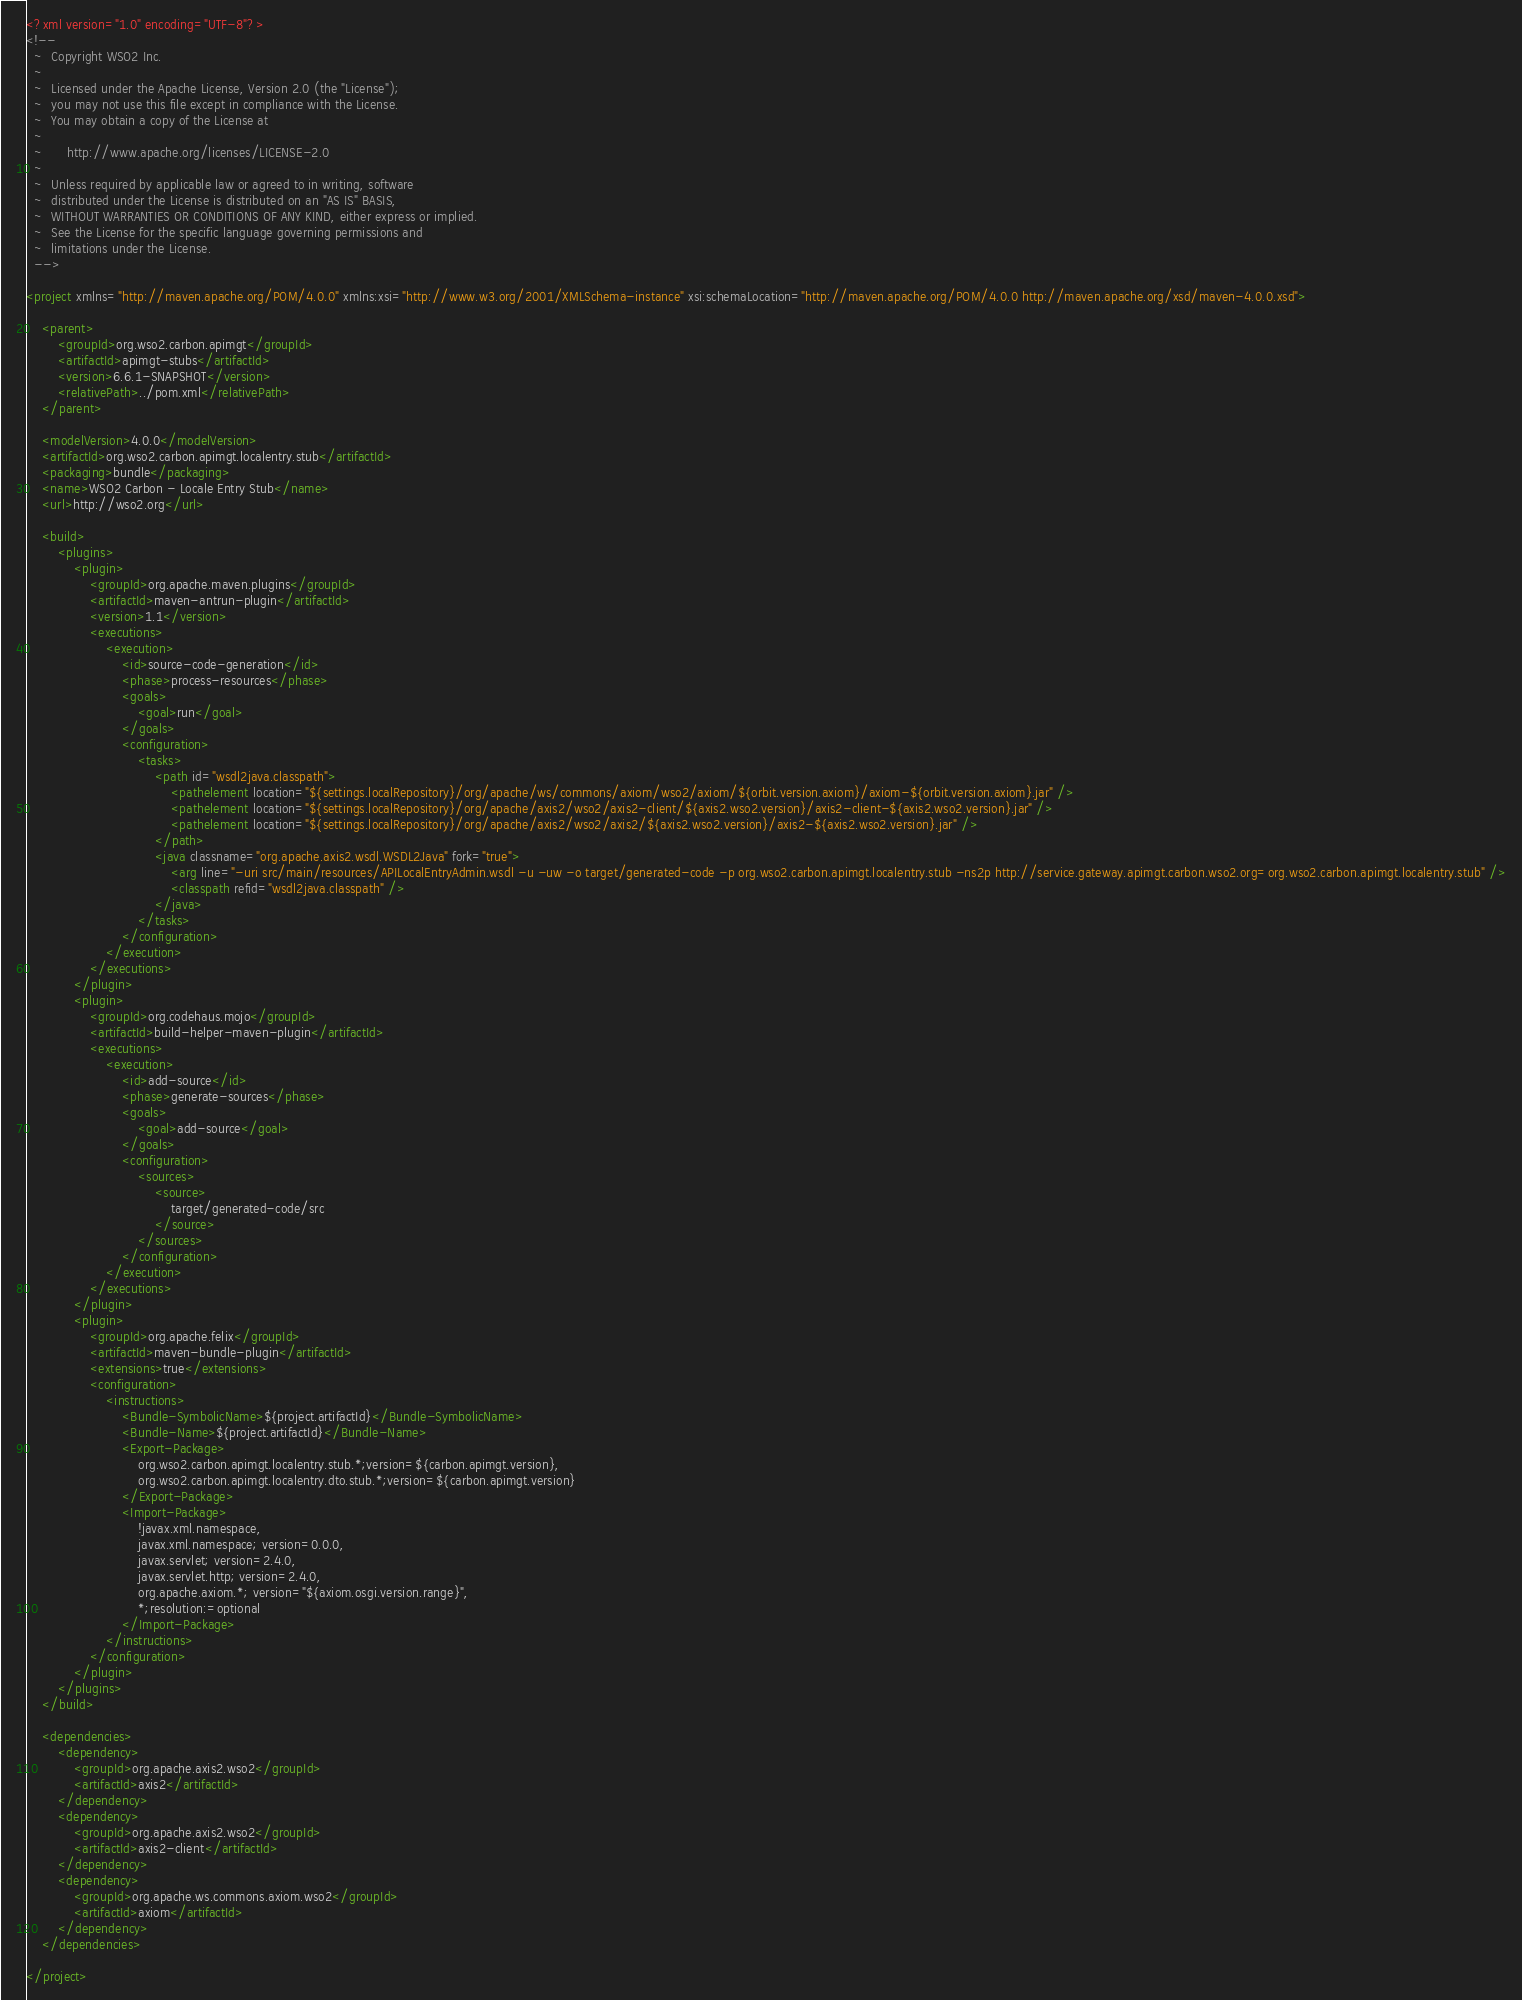Convert code to text. <code><loc_0><loc_0><loc_500><loc_500><_XML_><?xml version="1.0" encoding="UTF-8"?>
<!--
  ~  Copyright WSO2 Inc.
  ~
  ~  Licensed under the Apache License, Version 2.0 (the "License");
  ~  you may not use this file except in compliance with the License.
  ~  You may obtain a copy of the License at
  ~
  ~      http://www.apache.org/licenses/LICENSE-2.0
  ~
  ~  Unless required by applicable law or agreed to in writing, software
  ~  distributed under the License is distributed on an "AS IS" BASIS,
  ~  WITHOUT WARRANTIES OR CONDITIONS OF ANY KIND, either express or implied.
  ~  See the License for the specific language governing permissions and
  ~  limitations under the License.
  -->

<project xmlns="http://maven.apache.org/POM/4.0.0" xmlns:xsi="http://www.w3.org/2001/XMLSchema-instance" xsi:schemaLocation="http://maven.apache.org/POM/4.0.0 http://maven.apache.org/xsd/maven-4.0.0.xsd">

    <parent>
        <groupId>org.wso2.carbon.apimgt</groupId>
        <artifactId>apimgt-stubs</artifactId>
        <version>6.6.1-SNAPSHOT</version>
        <relativePath>../pom.xml</relativePath>
    </parent>

    <modelVersion>4.0.0</modelVersion>
    <artifactId>org.wso2.carbon.apimgt.localentry.stub</artifactId>
    <packaging>bundle</packaging>
    <name>WSO2 Carbon - Locale Entry Stub</name>
    <url>http://wso2.org</url>

    <build>
        <plugins>
            <plugin>
                <groupId>org.apache.maven.plugins</groupId>
                <artifactId>maven-antrun-plugin</artifactId>
                <version>1.1</version>
                <executions>
                    <execution>
                        <id>source-code-generation</id>
                        <phase>process-resources</phase>
                        <goals>
                            <goal>run</goal>
                        </goals>
                        <configuration>
                            <tasks>
                                <path id="wsdl2java.classpath">
                                    <pathelement location="${settings.localRepository}/org/apache/ws/commons/axiom/wso2/axiom/${orbit.version.axiom}/axiom-${orbit.version.axiom}.jar" />
                                    <pathelement location="${settings.localRepository}/org/apache/axis2/wso2/axis2-client/${axis2.wso2.version}/axis2-client-${axis2.wso2.version}.jar" />
                                    <pathelement location="${settings.localRepository}/org/apache/axis2/wso2/axis2/${axis2.wso2.version}/axis2-${axis2.wso2.version}.jar" />
                                </path>
                                <java classname="org.apache.axis2.wsdl.WSDL2Java" fork="true">
                                    <arg line="-uri src/main/resources/APILocalEntryAdmin.wsdl -u -uw -o target/generated-code -p org.wso2.carbon.apimgt.localentry.stub -ns2p http://service.gateway.apimgt.carbon.wso2.org=org.wso2.carbon.apimgt.localentry.stub" />
                                    <classpath refid="wsdl2java.classpath" />
                                </java>
                            </tasks>
                        </configuration>
                    </execution>
                </executions>
            </plugin>
            <plugin>
                <groupId>org.codehaus.mojo</groupId>
                <artifactId>build-helper-maven-plugin</artifactId>
                <executions>
                    <execution>
                        <id>add-source</id>
                        <phase>generate-sources</phase>
                        <goals>
                            <goal>add-source</goal>
                        </goals>
                        <configuration>
                            <sources>
                                <source>
                                    target/generated-code/src
                                </source>
                            </sources>
                        </configuration>
                    </execution>
                </executions>
            </plugin>
            <plugin>
                <groupId>org.apache.felix</groupId>
                <artifactId>maven-bundle-plugin</artifactId>
                <extensions>true</extensions>
                <configuration>
                    <instructions>
                        <Bundle-SymbolicName>${project.artifactId}</Bundle-SymbolicName>
                        <Bundle-Name>${project.artifactId}</Bundle-Name>
                        <Export-Package>
                            org.wso2.carbon.apimgt.localentry.stub.*;version=${carbon.apimgt.version},
                            org.wso2.carbon.apimgt.localentry.dto.stub.*;version=${carbon.apimgt.version}
                        </Export-Package>
                        <Import-Package>
                            !javax.xml.namespace,
                            javax.xml.namespace; version=0.0.0,
                            javax.servlet; version=2.4.0,
                            javax.servlet.http; version=2.4.0,
                            org.apache.axiom.*; version="${axiom.osgi.version.range}",
                            *;resolution:=optional
                        </Import-Package>
                    </instructions>
                </configuration>
            </plugin>
        </plugins>
    </build>

    <dependencies>
        <dependency>
            <groupId>org.apache.axis2.wso2</groupId>
            <artifactId>axis2</artifactId>
        </dependency>
        <dependency>
            <groupId>org.apache.axis2.wso2</groupId>
            <artifactId>axis2-client</artifactId>
        </dependency>
        <dependency>
            <groupId>org.apache.ws.commons.axiom.wso2</groupId>
            <artifactId>axiom</artifactId>
        </dependency>
    </dependencies>

</project></code> 